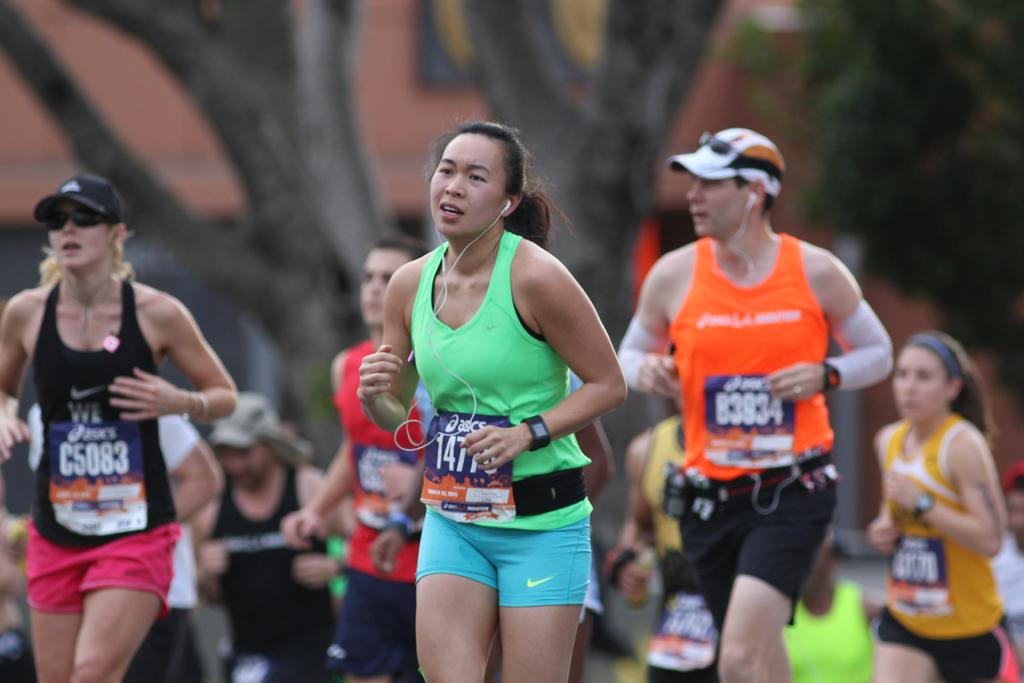<image>
Present a compact description of the photo's key features. A group of runners are running a marathon and one has the number C5083 on their shirt. 